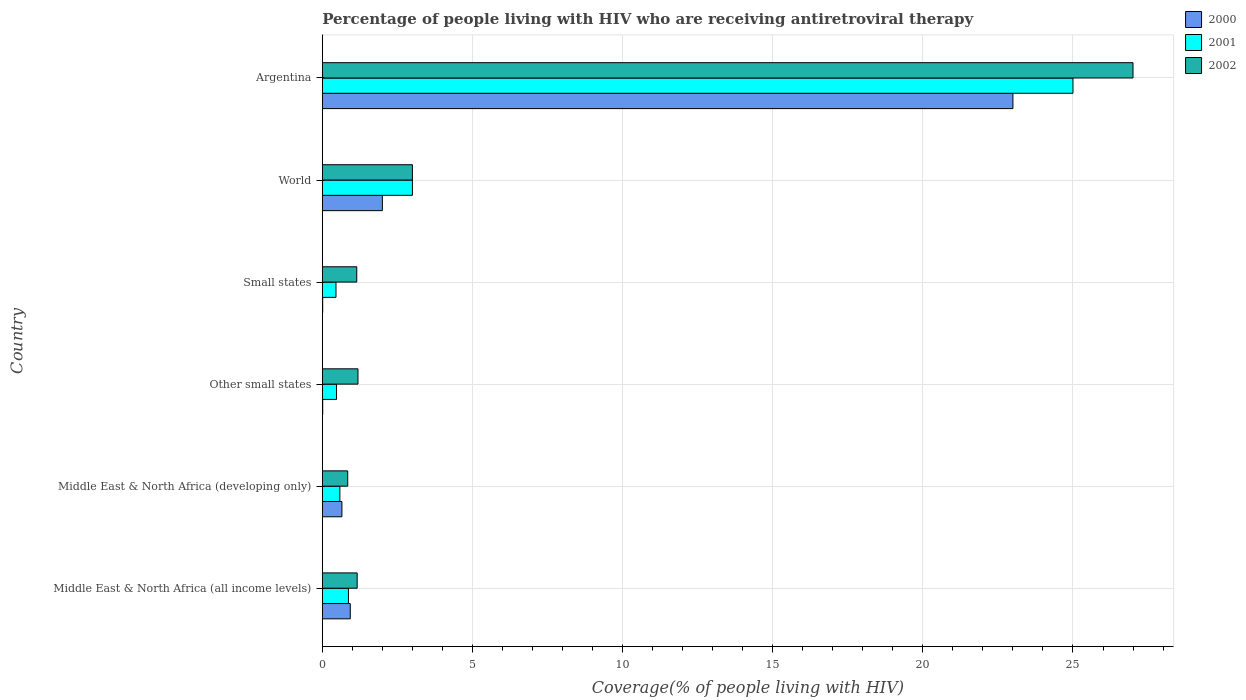How many different coloured bars are there?
Your answer should be very brief. 3. Are the number of bars per tick equal to the number of legend labels?
Your answer should be very brief. Yes. What is the label of the 4th group of bars from the top?
Provide a succinct answer. Other small states. In how many cases, is the number of bars for a given country not equal to the number of legend labels?
Your response must be concise. 0. What is the percentage of the HIV infected people who are receiving antiretroviral therapy in 2002 in Other small states?
Offer a very short reply. 1.19. Across all countries, what is the maximum percentage of the HIV infected people who are receiving antiretroviral therapy in 2001?
Give a very brief answer. 25. Across all countries, what is the minimum percentage of the HIV infected people who are receiving antiretroviral therapy in 2001?
Give a very brief answer. 0.45. In which country was the percentage of the HIV infected people who are receiving antiretroviral therapy in 2002 minimum?
Make the answer very short. Middle East & North Africa (developing only). What is the total percentage of the HIV infected people who are receiving antiretroviral therapy in 2002 in the graph?
Your answer should be very brief. 34.34. What is the difference between the percentage of the HIV infected people who are receiving antiretroviral therapy in 2002 in Small states and that in World?
Offer a terse response. -1.85. What is the difference between the percentage of the HIV infected people who are receiving antiretroviral therapy in 2002 in Argentina and the percentage of the HIV infected people who are receiving antiretroviral therapy in 2001 in Small states?
Keep it short and to the point. 26.55. What is the average percentage of the HIV infected people who are receiving antiretroviral therapy in 2002 per country?
Give a very brief answer. 5.72. What is the difference between the percentage of the HIV infected people who are receiving antiretroviral therapy in 2001 and percentage of the HIV infected people who are receiving antiretroviral therapy in 2000 in World?
Make the answer very short. 1. What is the ratio of the percentage of the HIV infected people who are receiving antiretroviral therapy in 2001 in Argentina to that in World?
Make the answer very short. 8.33. Is the percentage of the HIV infected people who are receiving antiretroviral therapy in 2002 in Middle East & North Africa (all income levels) less than that in Middle East & North Africa (developing only)?
Your answer should be compact. No. What is the difference between the highest and the second highest percentage of the HIV infected people who are receiving antiretroviral therapy in 2002?
Provide a succinct answer. 24. What is the difference between the highest and the lowest percentage of the HIV infected people who are receiving antiretroviral therapy in 2001?
Offer a terse response. 24.55. In how many countries, is the percentage of the HIV infected people who are receiving antiretroviral therapy in 2000 greater than the average percentage of the HIV infected people who are receiving antiretroviral therapy in 2000 taken over all countries?
Make the answer very short. 1. Is the sum of the percentage of the HIV infected people who are receiving antiretroviral therapy in 2002 in Argentina and Other small states greater than the maximum percentage of the HIV infected people who are receiving antiretroviral therapy in 2001 across all countries?
Make the answer very short. Yes. What does the 2nd bar from the bottom in Middle East & North Africa (all income levels) represents?
Your answer should be very brief. 2001. Are all the bars in the graph horizontal?
Your answer should be compact. Yes. Are the values on the major ticks of X-axis written in scientific E-notation?
Keep it short and to the point. No. Does the graph contain grids?
Keep it short and to the point. Yes. Where does the legend appear in the graph?
Your answer should be compact. Top right. What is the title of the graph?
Make the answer very short. Percentage of people living with HIV who are receiving antiretroviral therapy. What is the label or title of the X-axis?
Offer a terse response. Coverage(% of people living with HIV). What is the label or title of the Y-axis?
Offer a very short reply. Country. What is the Coverage(% of people living with HIV) of 2000 in Middle East & North Africa (all income levels)?
Provide a succinct answer. 0.93. What is the Coverage(% of people living with HIV) in 2001 in Middle East & North Africa (all income levels)?
Give a very brief answer. 0.87. What is the Coverage(% of people living with HIV) in 2002 in Middle East & North Africa (all income levels)?
Your response must be concise. 1.16. What is the Coverage(% of people living with HIV) of 2000 in Middle East & North Africa (developing only)?
Make the answer very short. 0.65. What is the Coverage(% of people living with HIV) in 2001 in Middle East & North Africa (developing only)?
Your answer should be very brief. 0.58. What is the Coverage(% of people living with HIV) of 2002 in Middle East & North Africa (developing only)?
Provide a succinct answer. 0.85. What is the Coverage(% of people living with HIV) in 2000 in Other small states?
Give a very brief answer. 0.01. What is the Coverage(% of people living with HIV) of 2001 in Other small states?
Ensure brevity in your answer.  0.47. What is the Coverage(% of people living with HIV) of 2002 in Other small states?
Your response must be concise. 1.19. What is the Coverage(% of people living with HIV) in 2000 in Small states?
Make the answer very short. 0.01. What is the Coverage(% of people living with HIV) in 2001 in Small states?
Offer a very short reply. 0.45. What is the Coverage(% of people living with HIV) of 2002 in Small states?
Ensure brevity in your answer.  1.15. What is the Coverage(% of people living with HIV) of 2000 in World?
Your response must be concise. 2. What is the Coverage(% of people living with HIV) in 2000 in Argentina?
Offer a terse response. 23. What is the Coverage(% of people living with HIV) in 2001 in Argentina?
Provide a short and direct response. 25. Across all countries, what is the maximum Coverage(% of people living with HIV) in 2000?
Offer a very short reply. 23. Across all countries, what is the maximum Coverage(% of people living with HIV) of 2001?
Keep it short and to the point. 25. Across all countries, what is the minimum Coverage(% of people living with HIV) in 2000?
Give a very brief answer. 0.01. Across all countries, what is the minimum Coverage(% of people living with HIV) of 2001?
Offer a very short reply. 0.45. Across all countries, what is the minimum Coverage(% of people living with HIV) of 2002?
Your answer should be compact. 0.85. What is the total Coverage(% of people living with HIV) of 2000 in the graph?
Give a very brief answer. 26.61. What is the total Coverage(% of people living with HIV) in 2001 in the graph?
Your response must be concise. 30.38. What is the total Coverage(% of people living with HIV) of 2002 in the graph?
Provide a short and direct response. 34.34. What is the difference between the Coverage(% of people living with HIV) of 2000 in Middle East & North Africa (all income levels) and that in Middle East & North Africa (developing only)?
Offer a very short reply. 0.28. What is the difference between the Coverage(% of people living with HIV) of 2001 in Middle East & North Africa (all income levels) and that in Middle East & North Africa (developing only)?
Offer a very short reply. 0.29. What is the difference between the Coverage(% of people living with HIV) in 2002 in Middle East & North Africa (all income levels) and that in Middle East & North Africa (developing only)?
Your response must be concise. 0.31. What is the difference between the Coverage(% of people living with HIV) of 2000 in Middle East & North Africa (all income levels) and that in Other small states?
Offer a terse response. 0.92. What is the difference between the Coverage(% of people living with HIV) in 2001 in Middle East & North Africa (all income levels) and that in Other small states?
Give a very brief answer. 0.4. What is the difference between the Coverage(% of people living with HIV) in 2002 in Middle East & North Africa (all income levels) and that in Other small states?
Ensure brevity in your answer.  -0.03. What is the difference between the Coverage(% of people living with HIV) in 2000 in Middle East & North Africa (all income levels) and that in Small states?
Give a very brief answer. 0.92. What is the difference between the Coverage(% of people living with HIV) of 2001 in Middle East & North Africa (all income levels) and that in Small states?
Provide a succinct answer. 0.42. What is the difference between the Coverage(% of people living with HIV) in 2002 in Middle East & North Africa (all income levels) and that in Small states?
Your response must be concise. 0.01. What is the difference between the Coverage(% of people living with HIV) in 2000 in Middle East & North Africa (all income levels) and that in World?
Your response must be concise. -1.07. What is the difference between the Coverage(% of people living with HIV) of 2001 in Middle East & North Africa (all income levels) and that in World?
Ensure brevity in your answer.  -2.13. What is the difference between the Coverage(% of people living with HIV) in 2002 in Middle East & North Africa (all income levels) and that in World?
Offer a very short reply. -1.84. What is the difference between the Coverage(% of people living with HIV) in 2000 in Middle East & North Africa (all income levels) and that in Argentina?
Offer a terse response. -22.07. What is the difference between the Coverage(% of people living with HIV) of 2001 in Middle East & North Africa (all income levels) and that in Argentina?
Offer a terse response. -24.13. What is the difference between the Coverage(% of people living with HIV) in 2002 in Middle East & North Africa (all income levels) and that in Argentina?
Your answer should be very brief. -25.84. What is the difference between the Coverage(% of people living with HIV) in 2000 in Middle East & North Africa (developing only) and that in Other small states?
Make the answer very short. 0.64. What is the difference between the Coverage(% of people living with HIV) of 2001 in Middle East & North Africa (developing only) and that in Other small states?
Provide a short and direct response. 0.11. What is the difference between the Coverage(% of people living with HIV) of 2002 in Middle East & North Africa (developing only) and that in Other small states?
Provide a succinct answer. -0.34. What is the difference between the Coverage(% of people living with HIV) in 2000 in Middle East & North Africa (developing only) and that in Small states?
Offer a very short reply. 0.64. What is the difference between the Coverage(% of people living with HIV) of 2001 in Middle East & North Africa (developing only) and that in Small states?
Provide a succinct answer. 0.13. What is the difference between the Coverage(% of people living with HIV) in 2002 in Middle East & North Africa (developing only) and that in Small states?
Provide a succinct answer. -0.3. What is the difference between the Coverage(% of people living with HIV) of 2000 in Middle East & North Africa (developing only) and that in World?
Your response must be concise. -1.35. What is the difference between the Coverage(% of people living with HIV) in 2001 in Middle East & North Africa (developing only) and that in World?
Give a very brief answer. -2.42. What is the difference between the Coverage(% of people living with HIV) in 2002 in Middle East & North Africa (developing only) and that in World?
Provide a succinct answer. -2.15. What is the difference between the Coverage(% of people living with HIV) of 2000 in Middle East & North Africa (developing only) and that in Argentina?
Give a very brief answer. -22.35. What is the difference between the Coverage(% of people living with HIV) of 2001 in Middle East & North Africa (developing only) and that in Argentina?
Your response must be concise. -24.42. What is the difference between the Coverage(% of people living with HIV) of 2002 in Middle East & North Africa (developing only) and that in Argentina?
Your answer should be very brief. -26.15. What is the difference between the Coverage(% of people living with HIV) in 2000 in Other small states and that in Small states?
Your answer should be very brief. 0. What is the difference between the Coverage(% of people living with HIV) in 2001 in Other small states and that in Small states?
Make the answer very short. 0.02. What is the difference between the Coverage(% of people living with HIV) in 2002 in Other small states and that in Small states?
Ensure brevity in your answer.  0.04. What is the difference between the Coverage(% of people living with HIV) in 2000 in Other small states and that in World?
Your answer should be compact. -1.99. What is the difference between the Coverage(% of people living with HIV) in 2001 in Other small states and that in World?
Ensure brevity in your answer.  -2.53. What is the difference between the Coverage(% of people living with HIV) of 2002 in Other small states and that in World?
Give a very brief answer. -1.81. What is the difference between the Coverage(% of people living with HIV) of 2000 in Other small states and that in Argentina?
Your response must be concise. -22.99. What is the difference between the Coverage(% of people living with HIV) in 2001 in Other small states and that in Argentina?
Offer a very short reply. -24.53. What is the difference between the Coverage(% of people living with HIV) in 2002 in Other small states and that in Argentina?
Your answer should be compact. -25.81. What is the difference between the Coverage(% of people living with HIV) of 2000 in Small states and that in World?
Make the answer very short. -1.99. What is the difference between the Coverage(% of people living with HIV) of 2001 in Small states and that in World?
Your answer should be very brief. -2.54. What is the difference between the Coverage(% of people living with HIV) in 2002 in Small states and that in World?
Offer a very short reply. -1.85. What is the difference between the Coverage(% of people living with HIV) of 2000 in Small states and that in Argentina?
Ensure brevity in your answer.  -22.99. What is the difference between the Coverage(% of people living with HIV) in 2001 in Small states and that in Argentina?
Make the answer very short. -24.55. What is the difference between the Coverage(% of people living with HIV) of 2002 in Small states and that in Argentina?
Provide a succinct answer. -25.85. What is the difference between the Coverage(% of people living with HIV) in 2000 in Middle East & North Africa (all income levels) and the Coverage(% of people living with HIV) in 2001 in Middle East & North Africa (developing only)?
Keep it short and to the point. 0.35. What is the difference between the Coverage(% of people living with HIV) of 2000 in Middle East & North Africa (all income levels) and the Coverage(% of people living with HIV) of 2002 in Middle East & North Africa (developing only)?
Provide a succinct answer. 0.08. What is the difference between the Coverage(% of people living with HIV) of 2001 in Middle East & North Africa (all income levels) and the Coverage(% of people living with HIV) of 2002 in Middle East & North Africa (developing only)?
Offer a terse response. 0.02. What is the difference between the Coverage(% of people living with HIV) in 2000 in Middle East & North Africa (all income levels) and the Coverage(% of people living with HIV) in 2001 in Other small states?
Give a very brief answer. 0.46. What is the difference between the Coverage(% of people living with HIV) of 2000 in Middle East & North Africa (all income levels) and the Coverage(% of people living with HIV) of 2002 in Other small states?
Offer a very short reply. -0.26. What is the difference between the Coverage(% of people living with HIV) of 2001 in Middle East & North Africa (all income levels) and the Coverage(% of people living with HIV) of 2002 in Other small states?
Provide a succinct answer. -0.32. What is the difference between the Coverage(% of people living with HIV) of 2000 in Middle East & North Africa (all income levels) and the Coverage(% of people living with HIV) of 2001 in Small states?
Your answer should be compact. 0.48. What is the difference between the Coverage(% of people living with HIV) of 2000 in Middle East & North Africa (all income levels) and the Coverage(% of people living with HIV) of 2002 in Small states?
Keep it short and to the point. -0.22. What is the difference between the Coverage(% of people living with HIV) in 2001 in Middle East & North Africa (all income levels) and the Coverage(% of people living with HIV) in 2002 in Small states?
Your answer should be compact. -0.28. What is the difference between the Coverage(% of people living with HIV) in 2000 in Middle East & North Africa (all income levels) and the Coverage(% of people living with HIV) in 2001 in World?
Offer a very short reply. -2.07. What is the difference between the Coverage(% of people living with HIV) of 2000 in Middle East & North Africa (all income levels) and the Coverage(% of people living with HIV) of 2002 in World?
Your response must be concise. -2.07. What is the difference between the Coverage(% of people living with HIV) of 2001 in Middle East & North Africa (all income levels) and the Coverage(% of people living with HIV) of 2002 in World?
Your response must be concise. -2.13. What is the difference between the Coverage(% of people living with HIV) in 2000 in Middle East & North Africa (all income levels) and the Coverage(% of people living with HIV) in 2001 in Argentina?
Provide a succinct answer. -24.07. What is the difference between the Coverage(% of people living with HIV) in 2000 in Middle East & North Africa (all income levels) and the Coverage(% of people living with HIV) in 2002 in Argentina?
Give a very brief answer. -26.07. What is the difference between the Coverage(% of people living with HIV) in 2001 in Middle East & North Africa (all income levels) and the Coverage(% of people living with HIV) in 2002 in Argentina?
Your answer should be very brief. -26.13. What is the difference between the Coverage(% of people living with HIV) in 2000 in Middle East & North Africa (developing only) and the Coverage(% of people living with HIV) in 2001 in Other small states?
Your answer should be very brief. 0.18. What is the difference between the Coverage(% of people living with HIV) in 2000 in Middle East & North Africa (developing only) and the Coverage(% of people living with HIV) in 2002 in Other small states?
Your answer should be very brief. -0.53. What is the difference between the Coverage(% of people living with HIV) in 2001 in Middle East & North Africa (developing only) and the Coverage(% of people living with HIV) in 2002 in Other small states?
Your answer should be compact. -0.6. What is the difference between the Coverage(% of people living with HIV) in 2000 in Middle East & North Africa (developing only) and the Coverage(% of people living with HIV) in 2001 in Small states?
Your answer should be very brief. 0.2. What is the difference between the Coverage(% of people living with HIV) in 2000 in Middle East & North Africa (developing only) and the Coverage(% of people living with HIV) in 2002 in Small states?
Offer a terse response. -0.49. What is the difference between the Coverage(% of people living with HIV) of 2001 in Middle East & North Africa (developing only) and the Coverage(% of people living with HIV) of 2002 in Small states?
Provide a short and direct response. -0.56. What is the difference between the Coverage(% of people living with HIV) of 2000 in Middle East & North Africa (developing only) and the Coverage(% of people living with HIV) of 2001 in World?
Keep it short and to the point. -2.35. What is the difference between the Coverage(% of people living with HIV) in 2000 in Middle East & North Africa (developing only) and the Coverage(% of people living with HIV) in 2002 in World?
Provide a short and direct response. -2.35. What is the difference between the Coverage(% of people living with HIV) in 2001 in Middle East & North Africa (developing only) and the Coverage(% of people living with HIV) in 2002 in World?
Your answer should be very brief. -2.42. What is the difference between the Coverage(% of people living with HIV) in 2000 in Middle East & North Africa (developing only) and the Coverage(% of people living with HIV) in 2001 in Argentina?
Keep it short and to the point. -24.35. What is the difference between the Coverage(% of people living with HIV) of 2000 in Middle East & North Africa (developing only) and the Coverage(% of people living with HIV) of 2002 in Argentina?
Offer a very short reply. -26.35. What is the difference between the Coverage(% of people living with HIV) in 2001 in Middle East & North Africa (developing only) and the Coverage(% of people living with HIV) in 2002 in Argentina?
Provide a succinct answer. -26.42. What is the difference between the Coverage(% of people living with HIV) in 2000 in Other small states and the Coverage(% of people living with HIV) in 2001 in Small states?
Offer a very short reply. -0.44. What is the difference between the Coverage(% of people living with HIV) of 2000 in Other small states and the Coverage(% of people living with HIV) of 2002 in Small states?
Ensure brevity in your answer.  -1.13. What is the difference between the Coverage(% of people living with HIV) of 2001 in Other small states and the Coverage(% of people living with HIV) of 2002 in Small states?
Your answer should be compact. -0.67. What is the difference between the Coverage(% of people living with HIV) of 2000 in Other small states and the Coverage(% of people living with HIV) of 2001 in World?
Offer a very short reply. -2.99. What is the difference between the Coverage(% of people living with HIV) in 2000 in Other small states and the Coverage(% of people living with HIV) in 2002 in World?
Your answer should be compact. -2.99. What is the difference between the Coverage(% of people living with HIV) of 2001 in Other small states and the Coverage(% of people living with HIV) of 2002 in World?
Give a very brief answer. -2.53. What is the difference between the Coverage(% of people living with HIV) in 2000 in Other small states and the Coverage(% of people living with HIV) in 2001 in Argentina?
Offer a terse response. -24.99. What is the difference between the Coverage(% of people living with HIV) in 2000 in Other small states and the Coverage(% of people living with HIV) in 2002 in Argentina?
Your answer should be very brief. -26.99. What is the difference between the Coverage(% of people living with HIV) of 2001 in Other small states and the Coverage(% of people living with HIV) of 2002 in Argentina?
Your answer should be compact. -26.53. What is the difference between the Coverage(% of people living with HIV) of 2000 in Small states and the Coverage(% of people living with HIV) of 2001 in World?
Your response must be concise. -2.99. What is the difference between the Coverage(% of people living with HIV) in 2000 in Small states and the Coverage(% of people living with HIV) in 2002 in World?
Offer a terse response. -2.99. What is the difference between the Coverage(% of people living with HIV) in 2001 in Small states and the Coverage(% of people living with HIV) in 2002 in World?
Give a very brief answer. -2.54. What is the difference between the Coverage(% of people living with HIV) of 2000 in Small states and the Coverage(% of people living with HIV) of 2001 in Argentina?
Your answer should be very brief. -24.99. What is the difference between the Coverage(% of people living with HIV) of 2000 in Small states and the Coverage(% of people living with HIV) of 2002 in Argentina?
Your answer should be compact. -26.99. What is the difference between the Coverage(% of people living with HIV) in 2001 in Small states and the Coverage(% of people living with HIV) in 2002 in Argentina?
Give a very brief answer. -26.55. What is the average Coverage(% of people living with HIV) in 2000 per country?
Provide a succinct answer. 4.43. What is the average Coverage(% of people living with HIV) in 2001 per country?
Your answer should be compact. 5.06. What is the average Coverage(% of people living with HIV) of 2002 per country?
Give a very brief answer. 5.72. What is the difference between the Coverage(% of people living with HIV) in 2000 and Coverage(% of people living with HIV) in 2001 in Middle East & North Africa (all income levels)?
Offer a very short reply. 0.06. What is the difference between the Coverage(% of people living with HIV) of 2000 and Coverage(% of people living with HIV) of 2002 in Middle East & North Africa (all income levels)?
Your answer should be compact. -0.23. What is the difference between the Coverage(% of people living with HIV) in 2001 and Coverage(% of people living with HIV) in 2002 in Middle East & North Africa (all income levels)?
Your answer should be compact. -0.29. What is the difference between the Coverage(% of people living with HIV) of 2000 and Coverage(% of people living with HIV) of 2001 in Middle East & North Africa (developing only)?
Give a very brief answer. 0.07. What is the difference between the Coverage(% of people living with HIV) in 2000 and Coverage(% of people living with HIV) in 2002 in Middle East & North Africa (developing only)?
Give a very brief answer. -0.19. What is the difference between the Coverage(% of people living with HIV) of 2001 and Coverage(% of people living with HIV) of 2002 in Middle East & North Africa (developing only)?
Offer a terse response. -0.26. What is the difference between the Coverage(% of people living with HIV) in 2000 and Coverage(% of people living with HIV) in 2001 in Other small states?
Your answer should be compact. -0.46. What is the difference between the Coverage(% of people living with HIV) in 2000 and Coverage(% of people living with HIV) in 2002 in Other small states?
Give a very brief answer. -1.17. What is the difference between the Coverage(% of people living with HIV) in 2001 and Coverage(% of people living with HIV) in 2002 in Other small states?
Make the answer very short. -0.71. What is the difference between the Coverage(% of people living with HIV) of 2000 and Coverage(% of people living with HIV) of 2001 in Small states?
Offer a terse response. -0.44. What is the difference between the Coverage(% of people living with HIV) in 2000 and Coverage(% of people living with HIV) in 2002 in Small states?
Offer a very short reply. -1.13. What is the difference between the Coverage(% of people living with HIV) of 2001 and Coverage(% of people living with HIV) of 2002 in Small states?
Keep it short and to the point. -0.69. What is the difference between the Coverage(% of people living with HIV) of 2001 and Coverage(% of people living with HIV) of 2002 in World?
Provide a short and direct response. 0. What is the difference between the Coverage(% of people living with HIV) in 2000 and Coverage(% of people living with HIV) in 2001 in Argentina?
Your answer should be very brief. -2. What is the difference between the Coverage(% of people living with HIV) in 2000 and Coverage(% of people living with HIV) in 2002 in Argentina?
Keep it short and to the point. -4. What is the difference between the Coverage(% of people living with HIV) of 2001 and Coverage(% of people living with HIV) of 2002 in Argentina?
Your answer should be compact. -2. What is the ratio of the Coverage(% of people living with HIV) of 2000 in Middle East & North Africa (all income levels) to that in Middle East & North Africa (developing only)?
Your response must be concise. 1.43. What is the ratio of the Coverage(% of people living with HIV) in 2001 in Middle East & North Africa (all income levels) to that in Middle East & North Africa (developing only)?
Your response must be concise. 1.49. What is the ratio of the Coverage(% of people living with HIV) in 2002 in Middle East & North Africa (all income levels) to that in Middle East & North Africa (developing only)?
Your answer should be compact. 1.37. What is the ratio of the Coverage(% of people living with HIV) in 2000 in Middle East & North Africa (all income levels) to that in Other small states?
Keep it short and to the point. 71.51. What is the ratio of the Coverage(% of people living with HIV) in 2001 in Middle East & North Africa (all income levels) to that in Other small states?
Your answer should be very brief. 1.84. What is the ratio of the Coverage(% of people living with HIV) of 2002 in Middle East & North Africa (all income levels) to that in Other small states?
Provide a short and direct response. 0.98. What is the ratio of the Coverage(% of people living with HIV) of 2000 in Middle East & North Africa (all income levels) to that in Small states?
Keep it short and to the point. 74.75. What is the ratio of the Coverage(% of people living with HIV) of 2001 in Middle East & North Africa (all income levels) to that in Small states?
Offer a terse response. 1.91. What is the ratio of the Coverage(% of people living with HIV) of 2002 in Middle East & North Africa (all income levels) to that in Small states?
Ensure brevity in your answer.  1.01. What is the ratio of the Coverage(% of people living with HIV) of 2000 in Middle East & North Africa (all income levels) to that in World?
Your response must be concise. 0.47. What is the ratio of the Coverage(% of people living with HIV) of 2001 in Middle East & North Africa (all income levels) to that in World?
Provide a succinct answer. 0.29. What is the ratio of the Coverage(% of people living with HIV) in 2002 in Middle East & North Africa (all income levels) to that in World?
Make the answer very short. 0.39. What is the ratio of the Coverage(% of people living with HIV) in 2000 in Middle East & North Africa (all income levels) to that in Argentina?
Your answer should be very brief. 0.04. What is the ratio of the Coverage(% of people living with HIV) in 2001 in Middle East & North Africa (all income levels) to that in Argentina?
Your answer should be compact. 0.03. What is the ratio of the Coverage(% of people living with HIV) of 2002 in Middle East & North Africa (all income levels) to that in Argentina?
Your response must be concise. 0.04. What is the ratio of the Coverage(% of people living with HIV) of 2000 in Middle East & North Africa (developing only) to that in Other small states?
Your response must be concise. 50.14. What is the ratio of the Coverage(% of people living with HIV) in 2001 in Middle East & North Africa (developing only) to that in Other small states?
Make the answer very short. 1.24. What is the ratio of the Coverage(% of people living with HIV) of 2002 in Middle East & North Africa (developing only) to that in Other small states?
Provide a short and direct response. 0.71. What is the ratio of the Coverage(% of people living with HIV) of 2000 in Middle East & North Africa (developing only) to that in Small states?
Make the answer very short. 52.41. What is the ratio of the Coverage(% of people living with HIV) of 2001 in Middle East & North Africa (developing only) to that in Small states?
Give a very brief answer. 1.28. What is the ratio of the Coverage(% of people living with HIV) of 2002 in Middle East & North Africa (developing only) to that in Small states?
Provide a short and direct response. 0.74. What is the ratio of the Coverage(% of people living with HIV) in 2000 in Middle East & North Africa (developing only) to that in World?
Give a very brief answer. 0.33. What is the ratio of the Coverage(% of people living with HIV) in 2001 in Middle East & North Africa (developing only) to that in World?
Ensure brevity in your answer.  0.19. What is the ratio of the Coverage(% of people living with HIV) in 2002 in Middle East & North Africa (developing only) to that in World?
Keep it short and to the point. 0.28. What is the ratio of the Coverage(% of people living with HIV) in 2000 in Middle East & North Africa (developing only) to that in Argentina?
Your response must be concise. 0.03. What is the ratio of the Coverage(% of people living with HIV) in 2001 in Middle East & North Africa (developing only) to that in Argentina?
Ensure brevity in your answer.  0.02. What is the ratio of the Coverage(% of people living with HIV) in 2002 in Middle East & North Africa (developing only) to that in Argentina?
Your answer should be compact. 0.03. What is the ratio of the Coverage(% of people living with HIV) of 2000 in Other small states to that in Small states?
Your answer should be very brief. 1.05. What is the ratio of the Coverage(% of people living with HIV) of 2001 in Other small states to that in Small states?
Your answer should be compact. 1.04. What is the ratio of the Coverage(% of people living with HIV) in 2002 in Other small states to that in Small states?
Your response must be concise. 1.04. What is the ratio of the Coverage(% of people living with HIV) of 2000 in Other small states to that in World?
Give a very brief answer. 0.01. What is the ratio of the Coverage(% of people living with HIV) of 2001 in Other small states to that in World?
Keep it short and to the point. 0.16. What is the ratio of the Coverage(% of people living with HIV) of 2002 in Other small states to that in World?
Your answer should be compact. 0.4. What is the ratio of the Coverage(% of people living with HIV) of 2000 in Other small states to that in Argentina?
Ensure brevity in your answer.  0. What is the ratio of the Coverage(% of people living with HIV) of 2001 in Other small states to that in Argentina?
Make the answer very short. 0.02. What is the ratio of the Coverage(% of people living with HIV) in 2002 in Other small states to that in Argentina?
Provide a short and direct response. 0.04. What is the ratio of the Coverage(% of people living with HIV) in 2000 in Small states to that in World?
Make the answer very short. 0.01. What is the ratio of the Coverage(% of people living with HIV) of 2001 in Small states to that in World?
Give a very brief answer. 0.15. What is the ratio of the Coverage(% of people living with HIV) of 2002 in Small states to that in World?
Give a very brief answer. 0.38. What is the ratio of the Coverage(% of people living with HIV) of 2000 in Small states to that in Argentina?
Give a very brief answer. 0. What is the ratio of the Coverage(% of people living with HIV) of 2001 in Small states to that in Argentina?
Offer a very short reply. 0.02. What is the ratio of the Coverage(% of people living with HIV) of 2002 in Small states to that in Argentina?
Make the answer very short. 0.04. What is the ratio of the Coverage(% of people living with HIV) in 2000 in World to that in Argentina?
Offer a terse response. 0.09. What is the ratio of the Coverage(% of people living with HIV) in 2001 in World to that in Argentina?
Make the answer very short. 0.12. What is the difference between the highest and the second highest Coverage(% of people living with HIV) of 2000?
Your answer should be very brief. 21. What is the difference between the highest and the second highest Coverage(% of people living with HIV) of 2001?
Give a very brief answer. 22. What is the difference between the highest and the lowest Coverage(% of people living with HIV) in 2000?
Offer a very short reply. 22.99. What is the difference between the highest and the lowest Coverage(% of people living with HIV) in 2001?
Your response must be concise. 24.55. What is the difference between the highest and the lowest Coverage(% of people living with HIV) of 2002?
Keep it short and to the point. 26.15. 